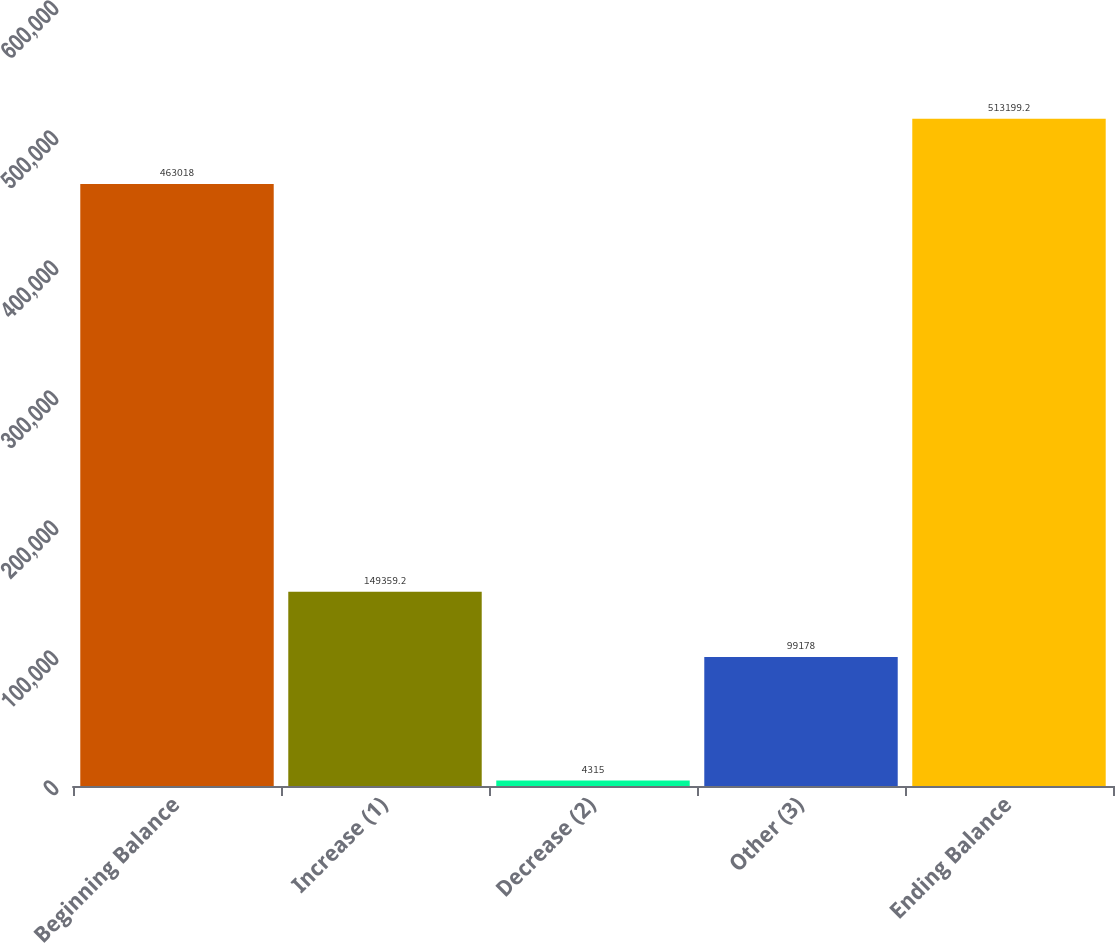Convert chart. <chart><loc_0><loc_0><loc_500><loc_500><bar_chart><fcel>Beginning Balance<fcel>Increase (1)<fcel>Decrease (2)<fcel>Other (3)<fcel>Ending Balance<nl><fcel>463018<fcel>149359<fcel>4315<fcel>99178<fcel>513199<nl></chart> 